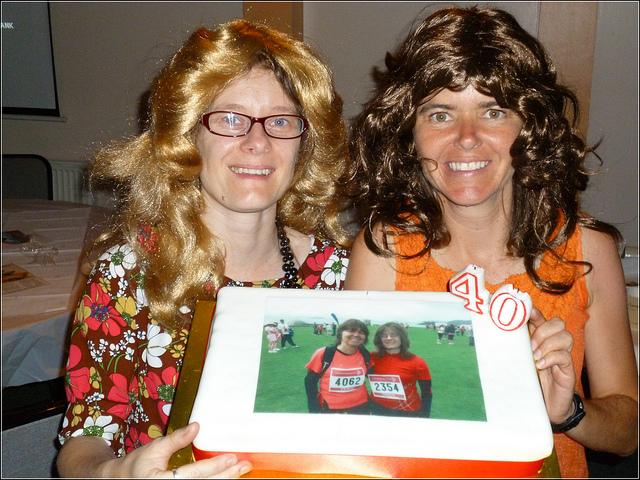Do identical twins have 100% the same DNA?

Choices:
A) somewhat
B) true
C) false
D) maybe true 